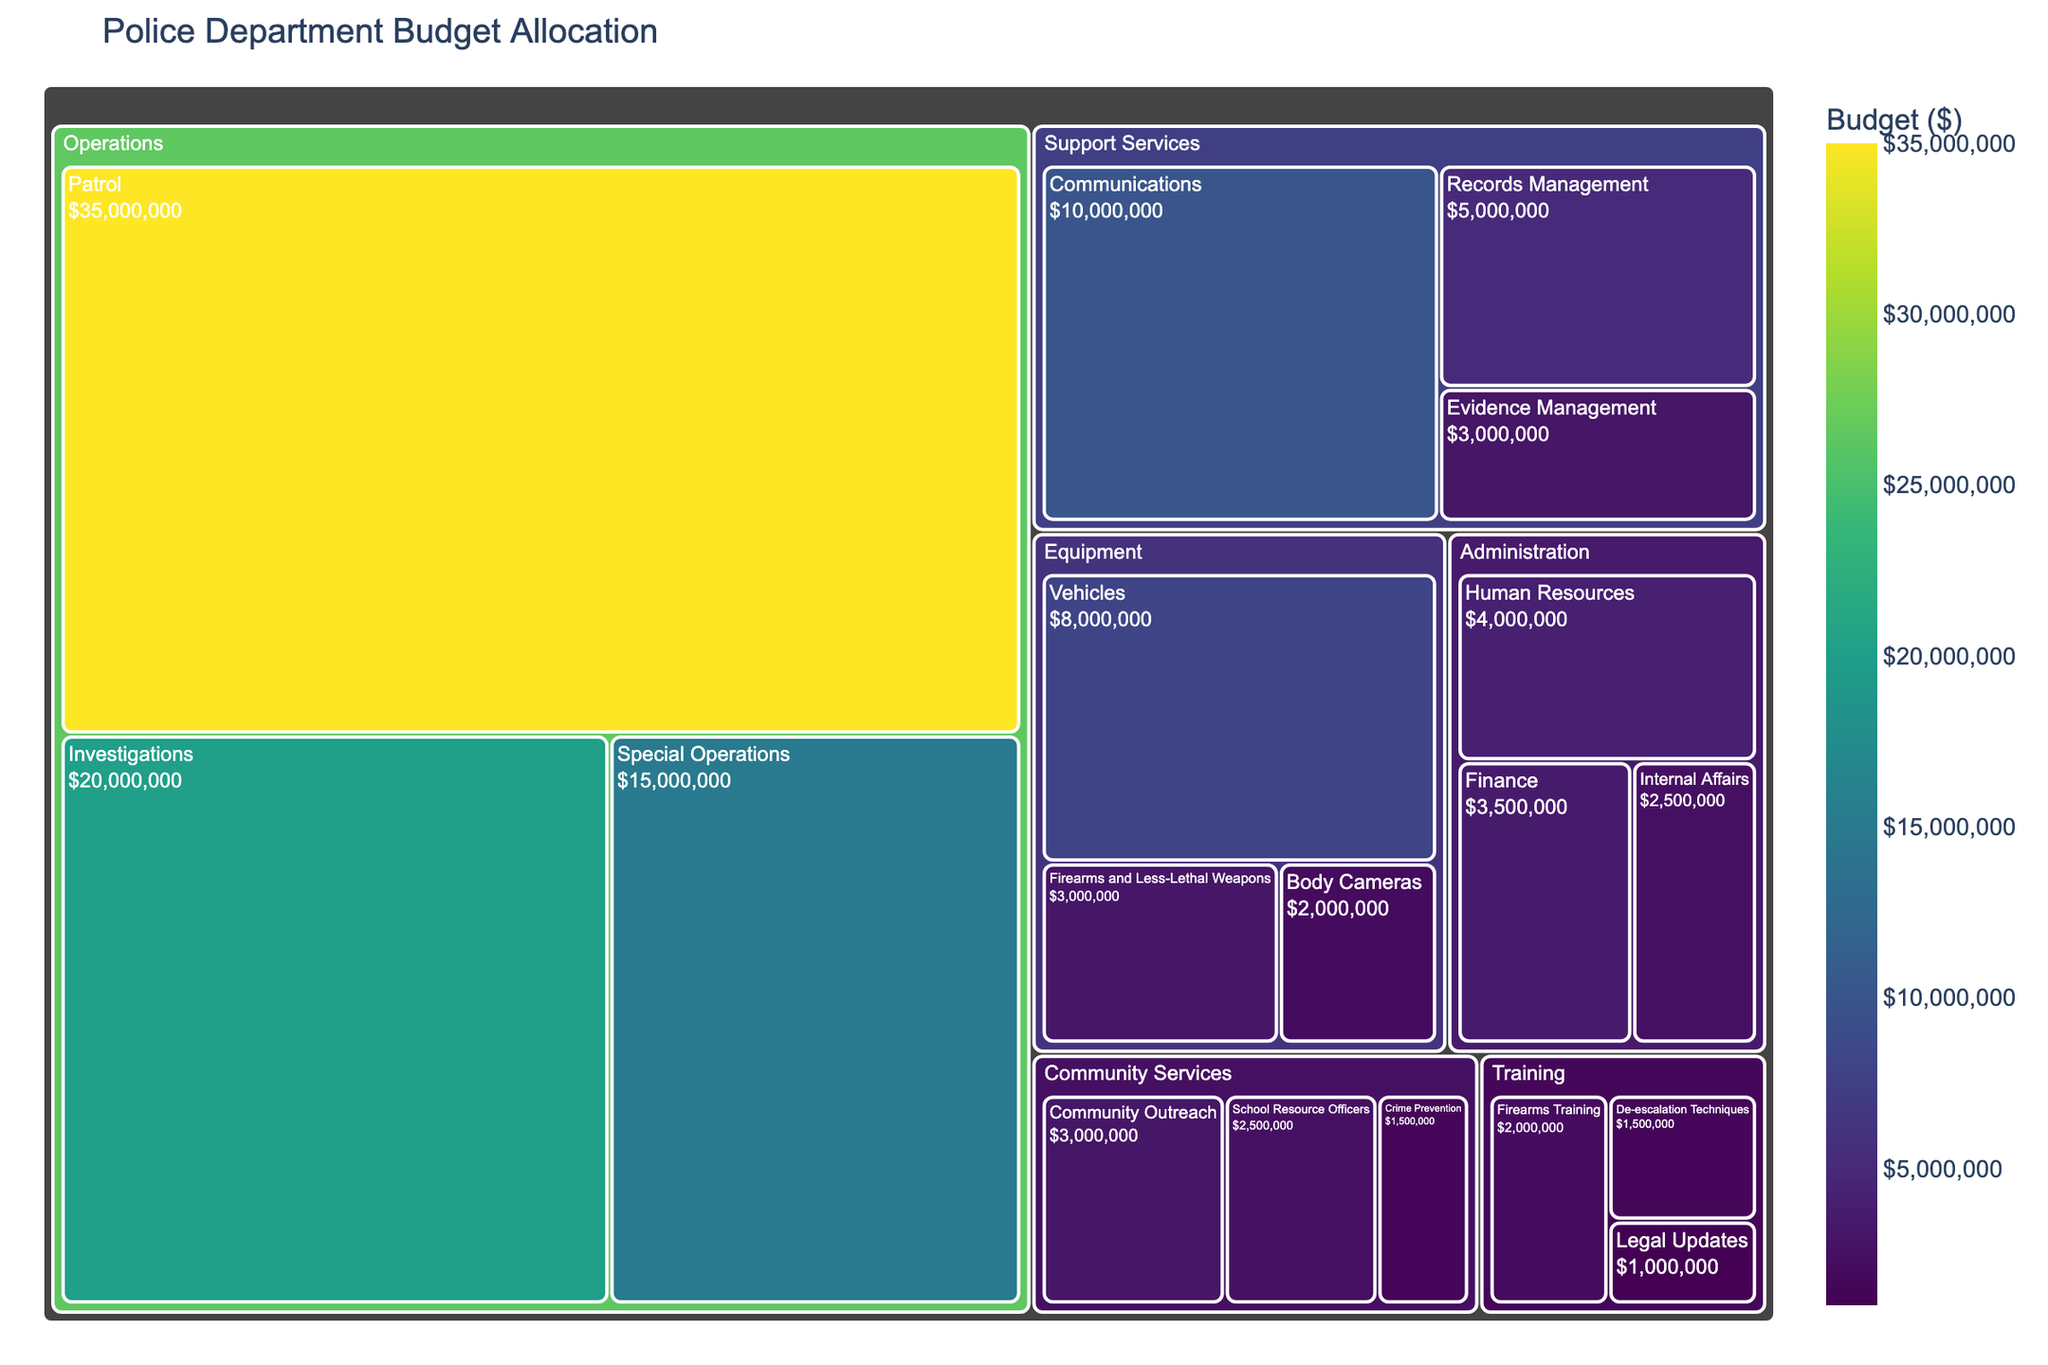What's the main title of the treemap? The main title is usually displayed prominently at the top of the treemap plot.
Answer: Police Department Budget Allocation Which category has the highest budget allocation? Look at the largest rectangle in the treemap, representing the category with the largest portion of the budget. Operations takes up the most space in the plot.
Answer: Operations What's the budget allocated to the 'Communications' subcategory? Find the 'Communications' section under 'Support Services' and read the budget value.
Answer: $10,000,000 How much more budget is allocated to 'Patrol' compared to 'Investigations'? Identify the budgets for 'Patrol' and 'Investigations' under the 'Operations' category and subtract the 'Investigations' budget from the 'Patrol' budget.
Answer: $15,000,000 What percentage of the total budget is dedicated to 'Training'? Add up all the budget allocations and then find the sum allocated to 'Training'. Divide the 'Training' budget by the total budget and multiply by 100 to get the percentage. The total budget is $12,000,000 out of $121,000,000.
Answer: Approximately 9.92% Which subcategory in the 'Equipment' category has the lowest budget? Compare the three subcategories under 'Equipment' and find the one with the smallest budget.
Answer: Body Cameras Do 'Human Resources' and 'Finance' combined have a higher budget than 'School Resource Officers'? Sum the budgets for 'Human Resources' and 'Finance', and compare this total to the budget for 'School Resource Officers'. $4,000,000 + $3,500,000 > $2,500,000
Answer: Yes Rank the subcategories in 'Operations' from highest to lowest budget. List the subcategories under 'Operations' in descending order by budget amount.
Answer: Patrol, Investigations, Special Operations How does the budget for 'De-escalation Techniques' compare to 'Firearms and Less-Lethal Weapons'? Compare the budget allocations for 'De-escalation Techniques' under 'Training' and 'Firearms and Less-Lethal Weapons' under 'Equipment'. $1,500,000 is less than $3,000,000
Answer: Less 